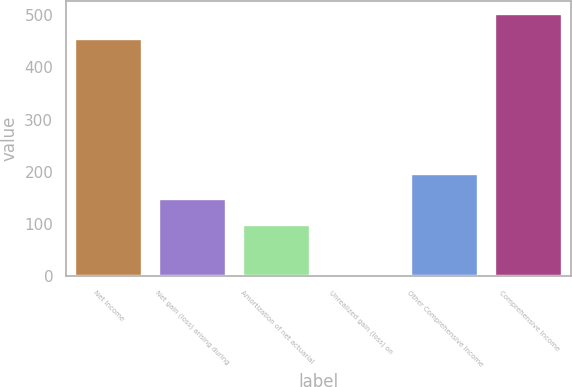Convert chart. <chart><loc_0><loc_0><loc_500><loc_500><bar_chart><fcel>Net Income<fcel>Net gain (loss) arising during<fcel>Amortization of net actuarial<fcel>Unrealized gain (loss) on<fcel>Other Comprehensive Income<fcel>Comprehensive Income<nl><fcel>454<fcel>147.5<fcel>99<fcel>2<fcel>196<fcel>502.5<nl></chart> 